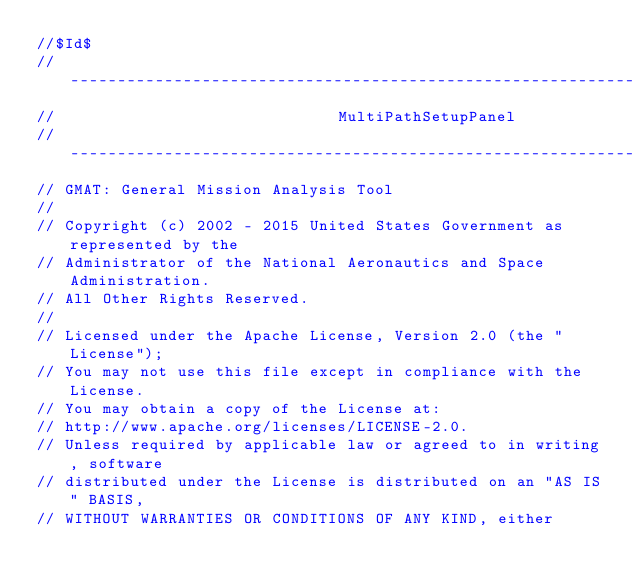Convert code to text. <code><loc_0><loc_0><loc_500><loc_500><_C++_>//$Id$
//------------------------------------------------------------------------------
//                              MultiPathSetupPanel
//------------------------------------------------------------------------------
// GMAT: General Mission Analysis Tool
//
// Copyright (c) 2002 - 2015 United States Government as represented by the
// Administrator of the National Aeronautics and Space Administration.
// All Other Rights Reserved.
//
// Licensed under the Apache License, Version 2.0 (the "License"); 
// You may not use this file except in compliance with the License. 
// You may obtain a copy of the License at:
// http://www.apache.org/licenses/LICENSE-2.0. 
// Unless required by applicable law or agreed to in writing, software
// distributed under the License is distributed on an "AS IS" BASIS,
// WITHOUT WARRANTIES OR CONDITIONS OF ANY KIND, either </code> 